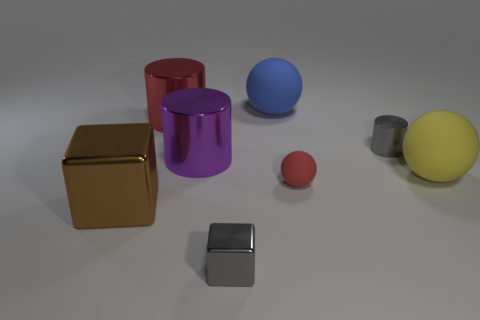Add 2 tiny gray shiny cubes. How many objects exist? 10 Subtract all cubes. How many objects are left? 6 Subtract all purple cylinders. Subtract all big red objects. How many objects are left? 6 Add 3 metallic cylinders. How many metallic cylinders are left? 6 Add 5 blue metallic things. How many blue metallic things exist? 5 Subtract 1 red balls. How many objects are left? 7 